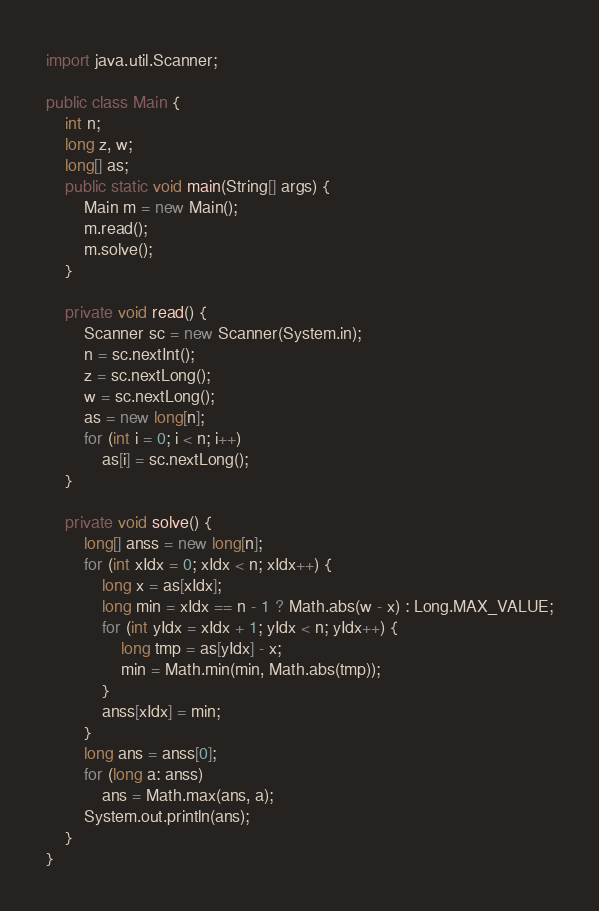Convert code to text. <code><loc_0><loc_0><loc_500><loc_500><_Java_>import java.util.Scanner;

public class Main {
    int n;
    long z, w;
    long[] as;
    public static void main(String[] args) {
        Main m = new Main();
        m.read();
        m.solve();
    }

    private void read() {
        Scanner sc = new Scanner(System.in);
        n = sc.nextInt();
        z = sc.nextLong();
        w = sc.nextLong();
        as = new long[n];
        for (int i = 0; i < n; i++)
            as[i] = sc.nextLong();
    }

    private void solve() {
        long[] anss = new long[n];
        for (int xIdx = 0; xIdx < n; xIdx++) {
            long x = as[xIdx];
            long min = xIdx == n - 1 ? Math.abs(w - x) : Long.MAX_VALUE;
            for (int yIdx = xIdx + 1; yIdx < n; yIdx++) {
                long tmp = as[yIdx] - x;
                min = Math.min(min, Math.abs(tmp));
            }
            anss[xIdx] = min;
        }
        long ans = anss[0];
        for (long a: anss)
            ans = Math.max(ans, a);
        System.out.println(ans);
    }
}
</code> 